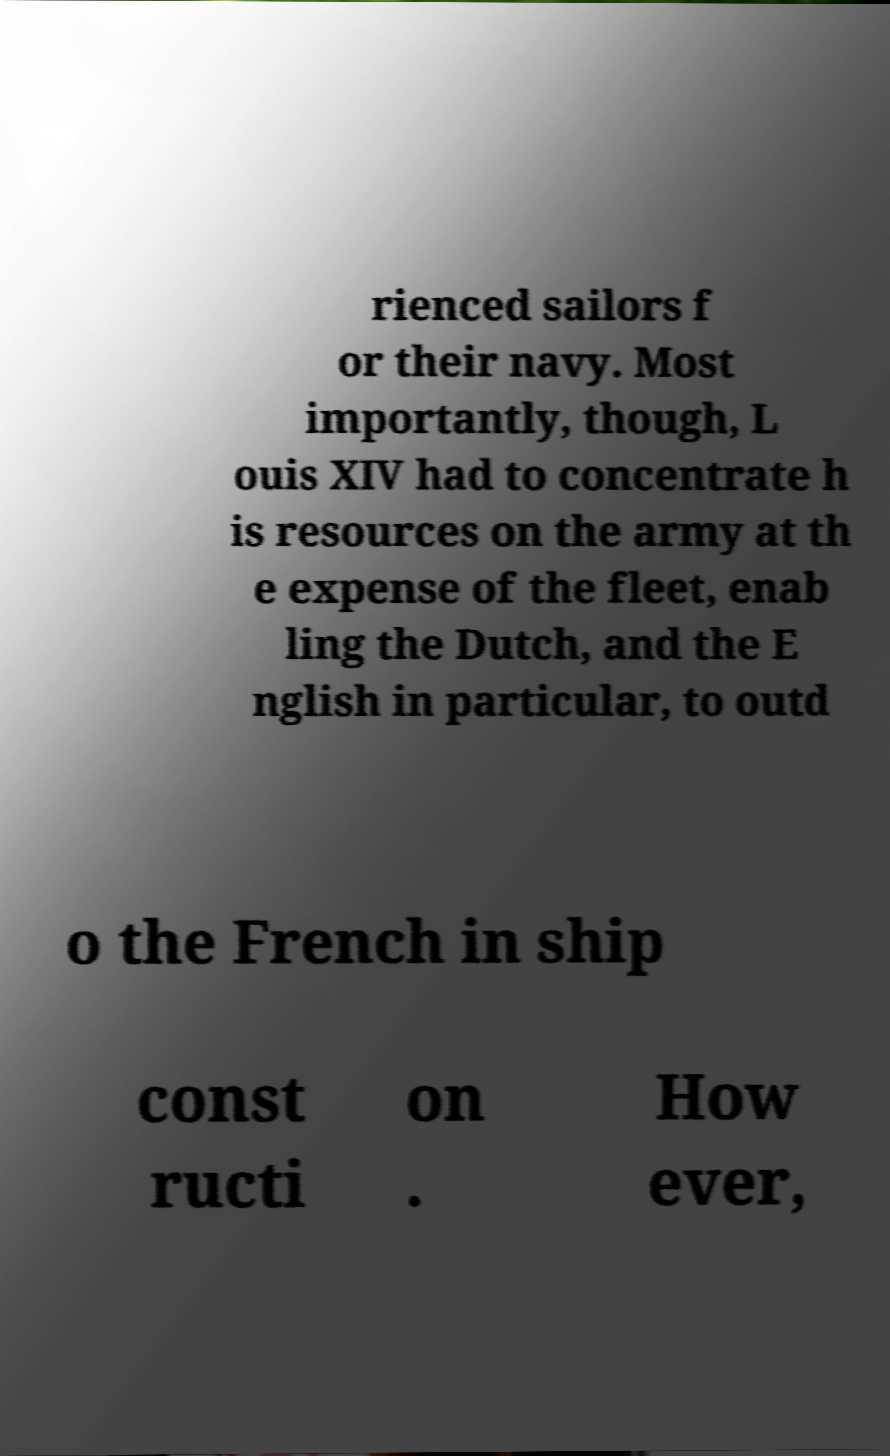There's text embedded in this image that I need extracted. Can you transcribe it verbatim? rienced sailors f or their navy. Most importantly, though, L ouis XIV had to concentrate h is resources on the army at th e expense of the fleet, enab ling the Dutch, and the E nglish in particular, to outd o the French in ship const ructi on . How ever, 